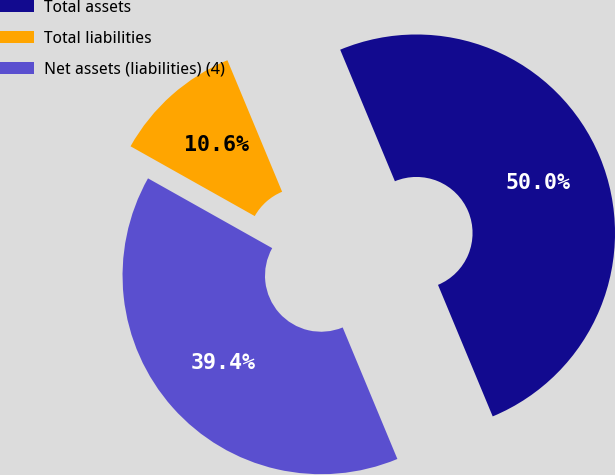Convert chart to OTSL. <chart><loc_0><loc_0><loc_500><loc_500><pie_chart><fcel>Total assets<fcel>Total liabilities<fcel>Net assets (liabilities) (4)<nl><fcel>50.0%<fcel>10.58%<fcel>39.42%<nl></chart> 